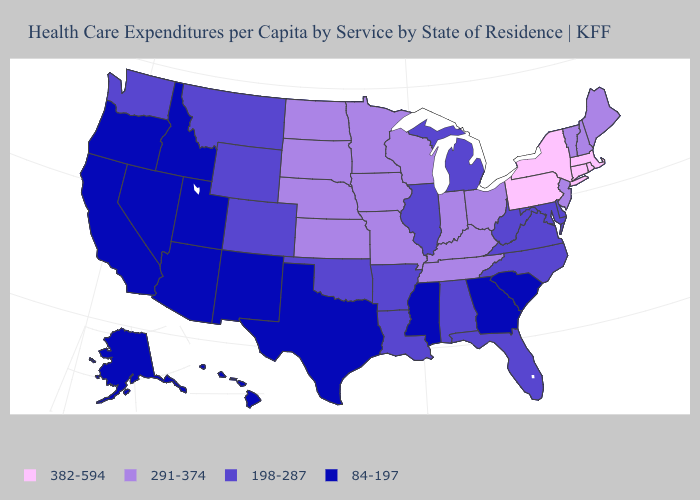Name the states that have a value in the range 198-287?
Concise answer only. Alabama, Arkansas, Colorado, Delaware, Florida, Illinois, Louisiana, Maryland, Michigan, Montana, North Carolina, Oklahoma, Virginia, Washington, West Virginia, Wyoming. Among the states that border Alabama , does Tennessee have the highest value?
Keep it brief. Yes. What is the value of Wyoming?
Keep it brief. 198-287. Which states hav the highest value in the Northeast?
Short answer required. Connecticut, Massachusetts, New York, Pennsylvania, Rhode Island. What is the highest value in the South ?
Quick response, please. 291-374. Name the states that have a value in the range 382-594?
Concise answer only. Connecticut, Massachusetts, New York, Pennsylvania, Rhode Island. What is the value of Alabama?
Give a very brief answer. 198-287. Which states have the highest value in the USA?
Give a very brief answer. Connecticut, Massachusetts, New York, Pennsylvania, Rhode Island. What is the value of Washington?
Write a very short answer. 198-287. What is the highest value in the USA?
Quick response, please. 382-594. Name the states that have a value in the range 291-374?
Be succinct. Indiana, Iowa, Kansas, Kentucky, Maine, Minnesota, Missouri, Nebraska, New Hampshire, New Jersey, North Dakota, Ohio, South Dakota, Tennessee, Vermont, Wisconsin. How many symbols are there in the legend?
Give a very brief answer. 4. Does California have a lower value than Kansas?
Be succinct. Yes. Name the states that have a value in the range 382-594?
Keep it brief. Connecticut, Massachusetts, New York, Pennsylvania, Rhode Island. Does Vermont have the lowest value in the USA?
Be succinct. No. 